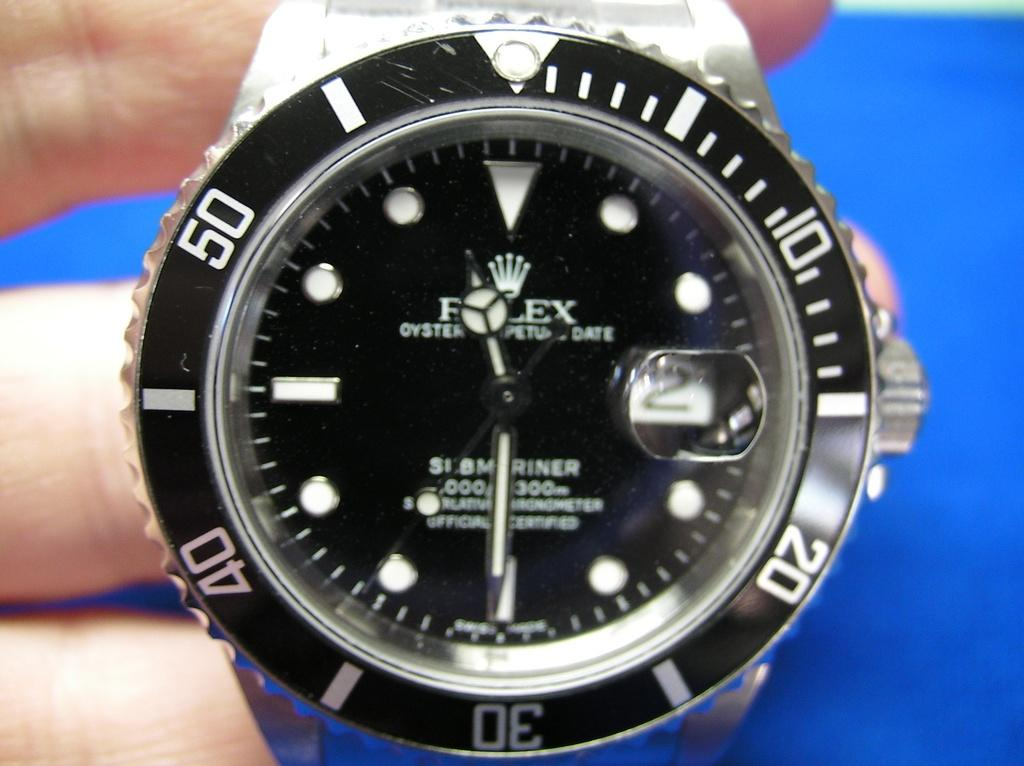<image>
Offer a succinct explanation of the picture presented. A black Rolex watch that has an Oyster Perpetual Date on it. 